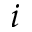<formula> <loc_0><loc_0><loc_500><loc_500>i</formula> 